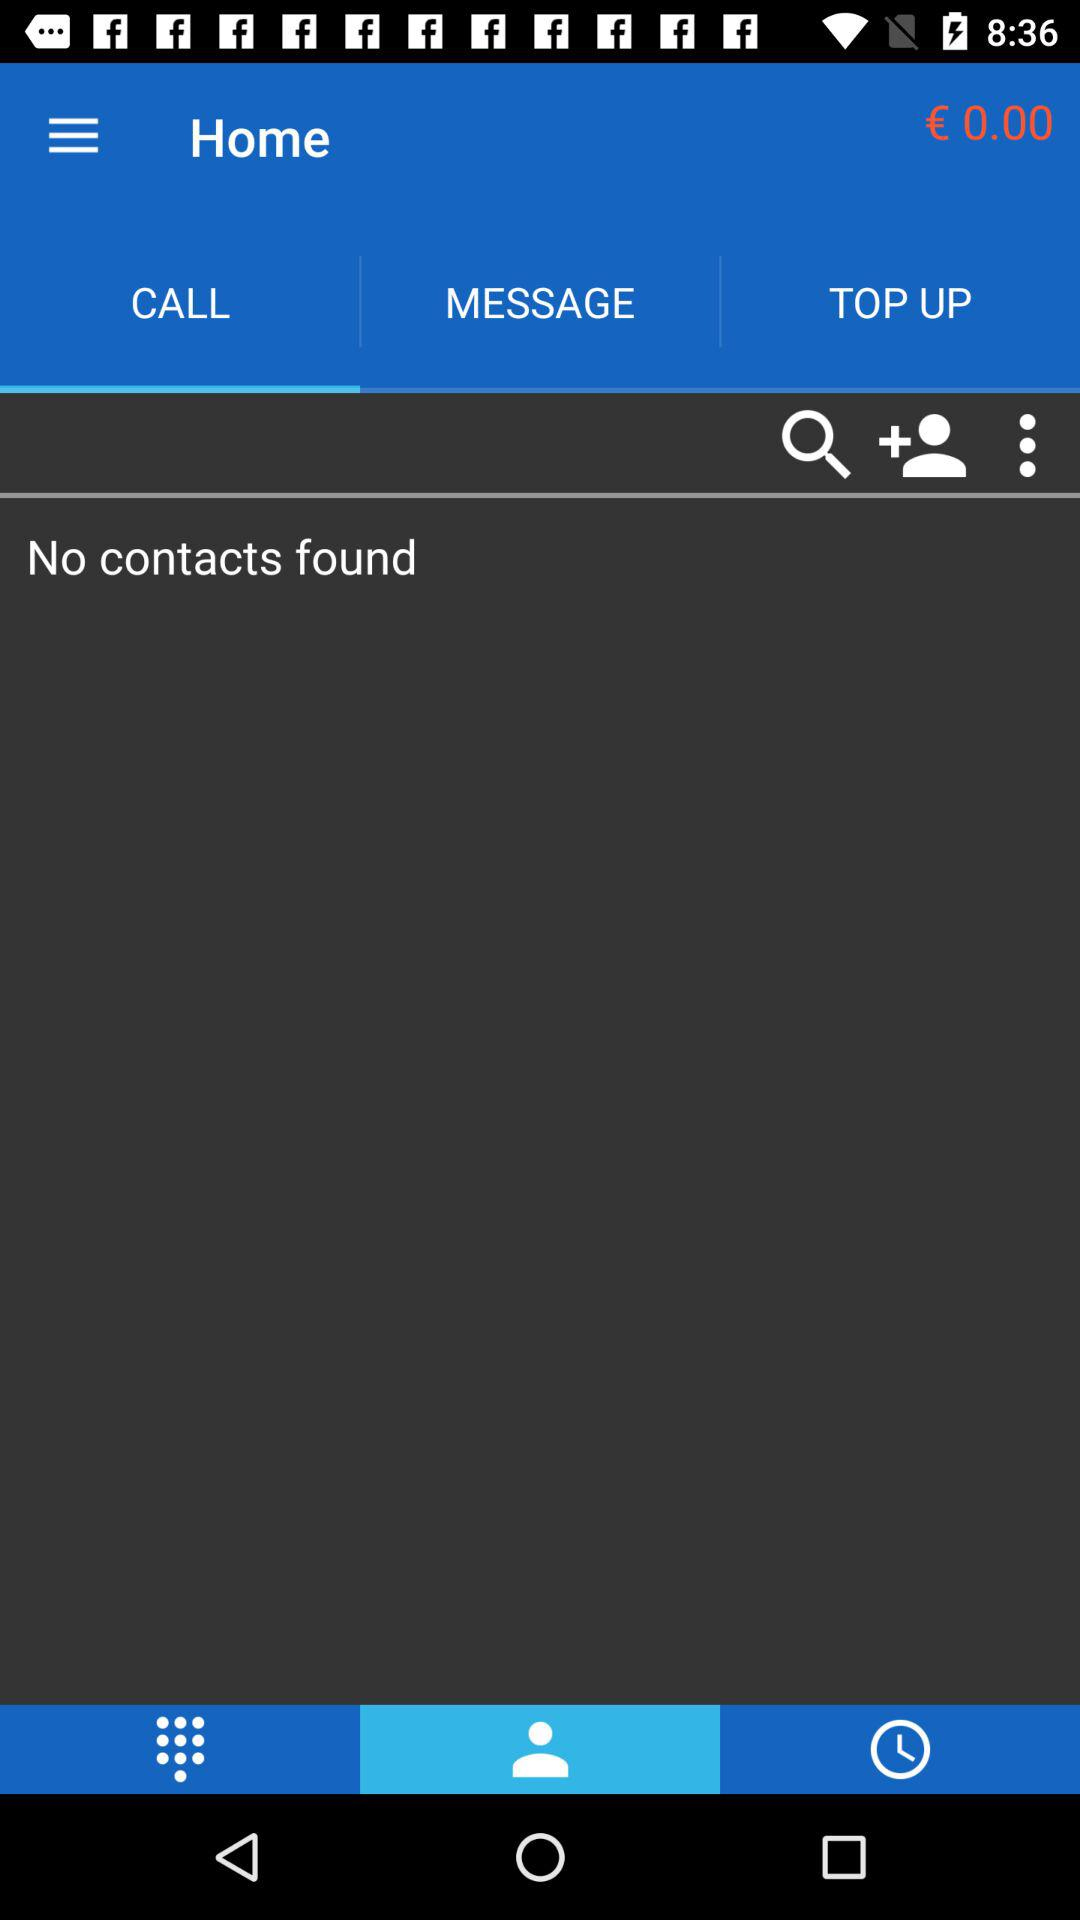How much money do I have?
Answer the question using a single word or phrase. € 0.00 